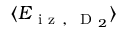<formula> <loc_0><loc_0><loc_500><loc_500>\langle E _ { i z , D _ { 2 } } \rangle</formula> 